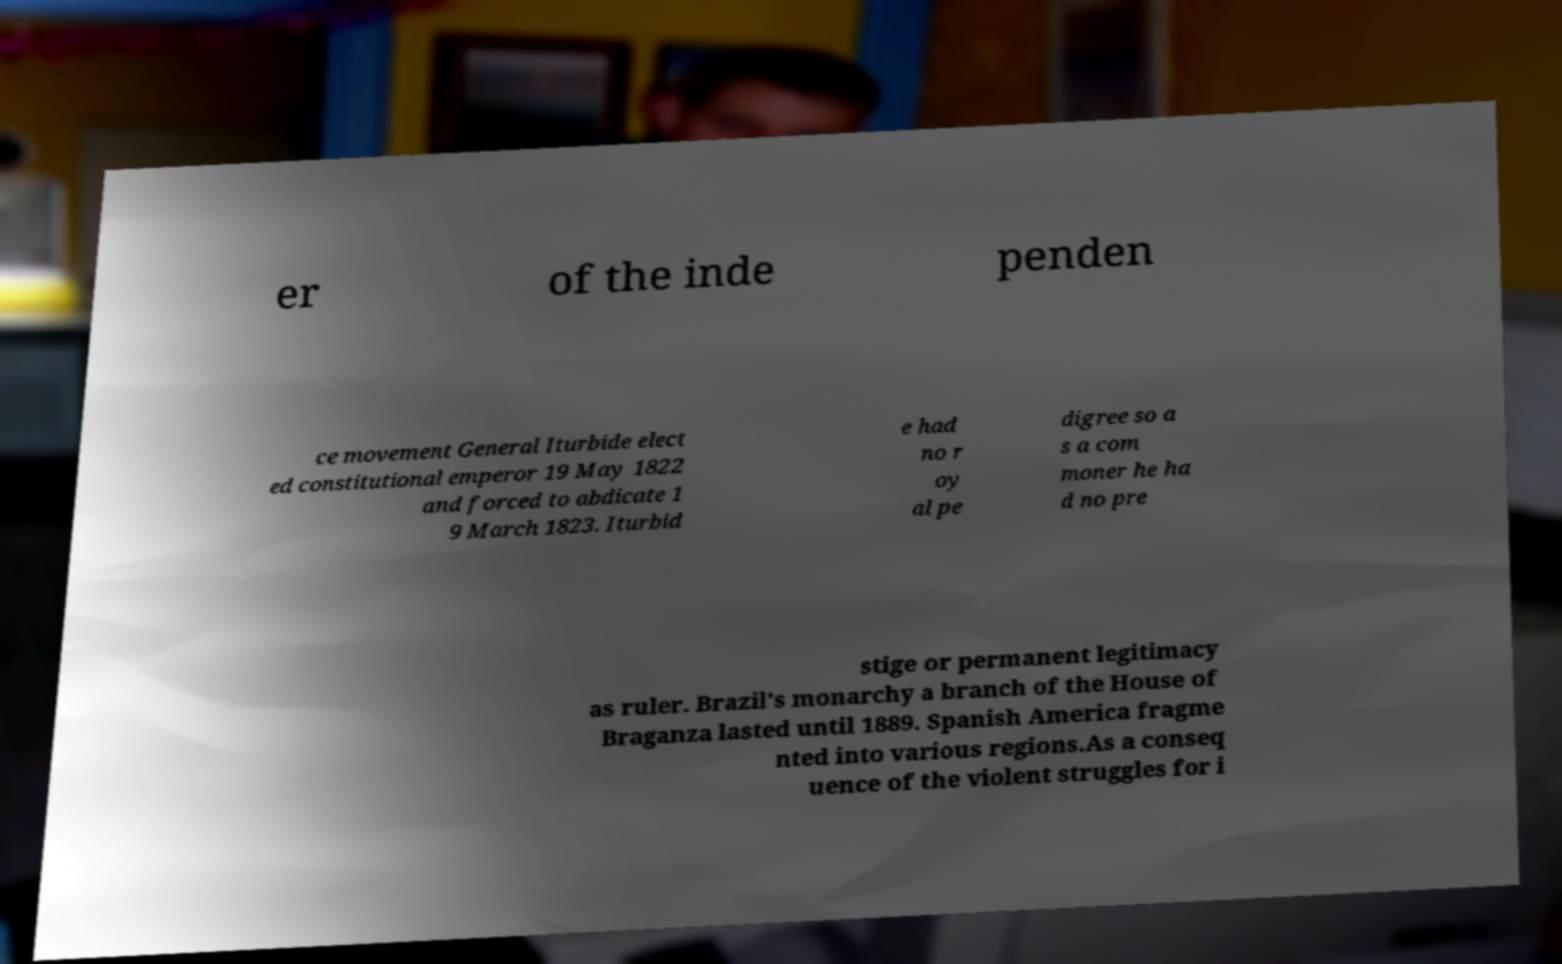For documentation purposes, I need the text within this image transcribed. Could you provide that? er of the inde penden ce movement General Iturbide elect ed constitutional emperor 19 May 1822 and forced to abdicate 1 9 March 1823. Iturbid e had no r oy al pe digree so a s a com moner he ha d no pre stige or permanent legitimacy as ruler. Brazil's monarchy a branch of the House of Braganza lasted until 1889. Spanish America fragme nted into various regions.As a conseq uence of the violent struggles for i 